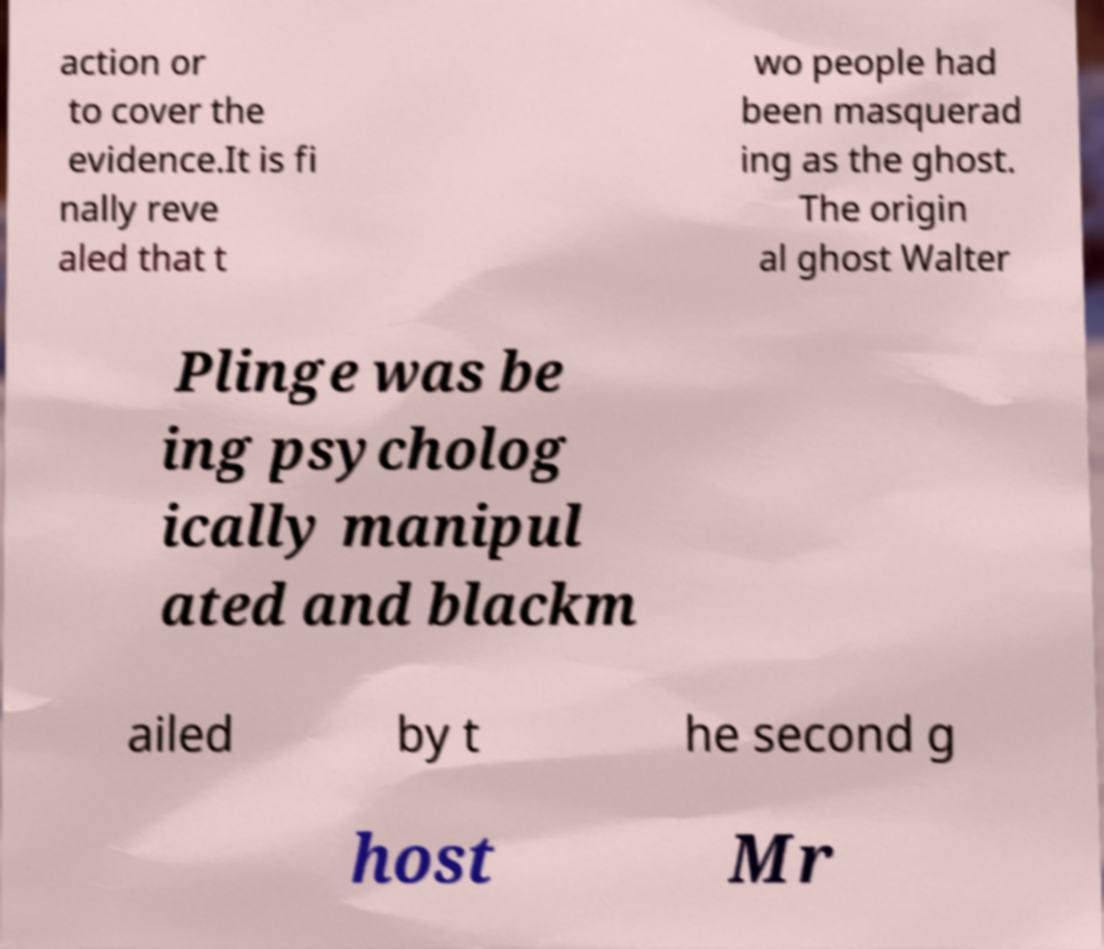Could you extract and type out the text from this image? action or to cover the evidence.It is fi nally reve aled that t wo people had been masquerad ing as the ghost. The origin al ghost Walter Plinge was be ing psycholog ically manipul ated and blackm ailed by t he second g host Mr 